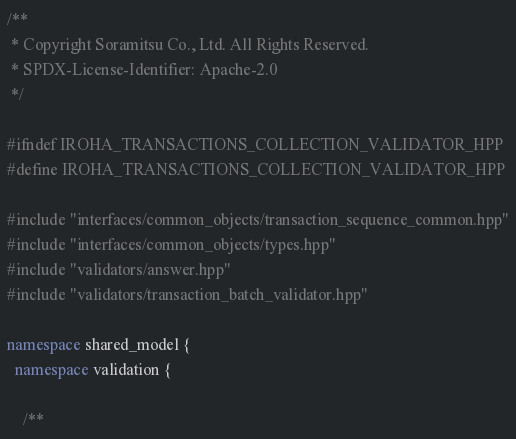<code> <loc_0><loc_0><loc_500><loc_500><_C++_>/**
 * Copyright Soramitsu Co., Ltd. All Rights Reserved.
 * SPDX-License-Identifier: Apache-2.0
 */

#ifndef IROHA_TRANSACTIONS_COLLECTION_VALIDATOR_HPP
#define IROHA_TRANSACTIONS_COLLECTION_VALIDATOR_HPP

#include "interfaces/common_objects/transaction_sequence_common.hpp"
#include "interfaces/common_objects/types.hpp"
#include "validators/answer.hpp"
#include "validators/transaction_batch_validator.hpp"

namespace shared_model {
  namespace validation {

    /**</code> 